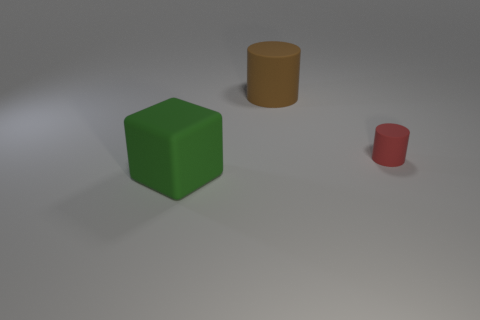There is another object that is the same shape as the red rubber object; what is its color?
Keep it short and to the point. Brown. What number of big rubber cubes are the same color as the tiny matte object?
Give a very brief answer. 0. The green thing is what size?
Provide a succinct answer. Large. Do the green cube and the brown object have the same size?
Your answer should be compact. Yes. What color is the rubber object that is both to the left of the red cylinder and behind the green rubber thing?
Offer a very short reply. Brown. How many large cylinders have the same material as the block?
Your answer should be very brief. 1. What number of large objects are there?
Make the answer very short. 2. There is a cube; is its size the same as the rubber cylinder that is behind the small matte object?
Ensure brevity in your answer.  Yes. What material is the large thing behind the matte thing that is left of the big cylinder?
Provide a succinct answer. Rubber. There is a object to the left of the large object that is behind the matte object on the left side of the brown cylinder; how big is it?
Give a very brief answer. Large. 